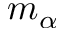<formula> <loc_0><loc_0><loc_500><loc_500>m _ { \alpha }</formula> 